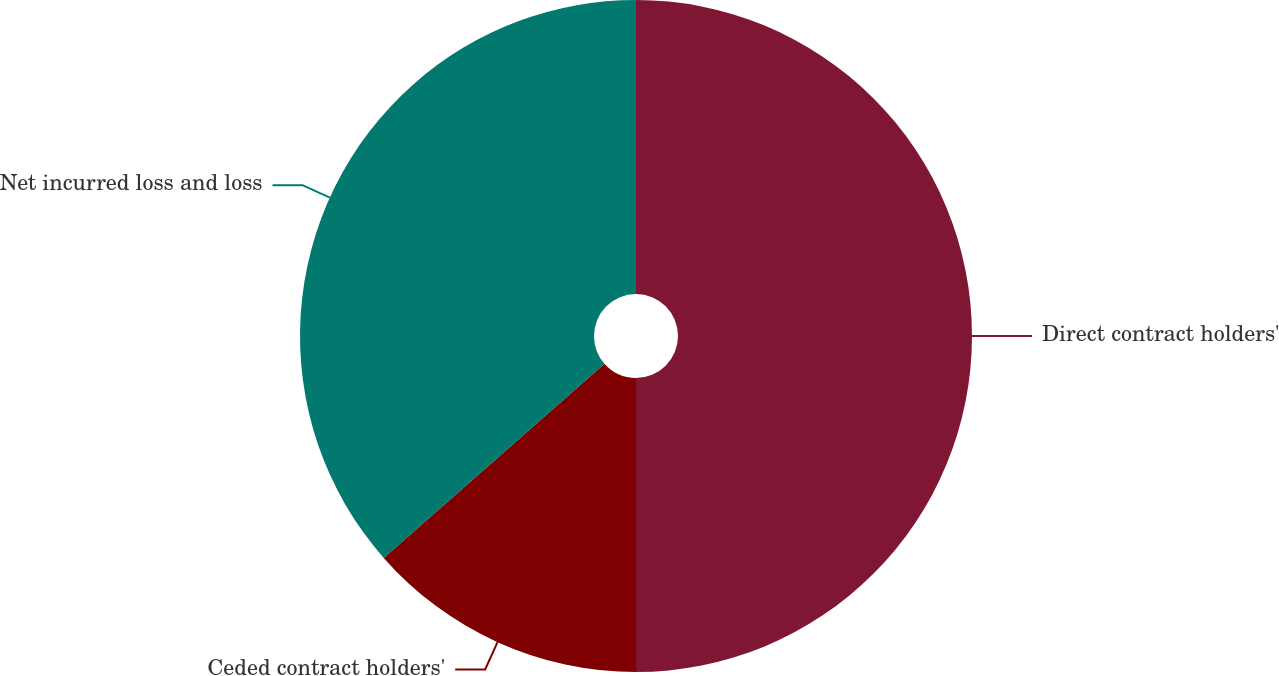<chart> <loc_0><loc_0><loc_500><loc_500><pie_chart><fcel>Direct contract holders'<fcel>Ceded contract holders'<fcel>Net incurred loss and loss<nl><fcel>50.0%<fcel>13.52%<fcel>36.48%<nl></chart> 